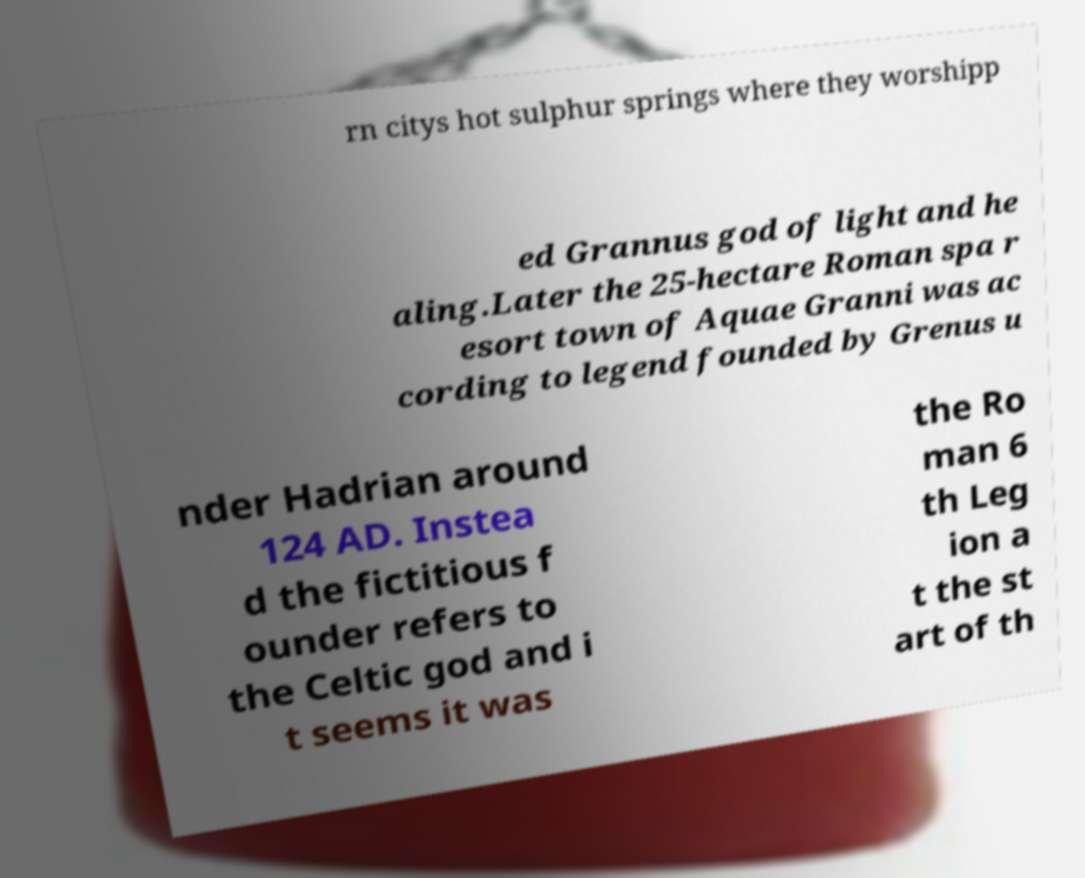Can you accurately transcribe the text from the provided image for me? rn citys hot sulphur springs where they worshipp ed Grannus god of light and he aling.Later the 25-hectare Roman spa r esort town of Aquae Granni was ac cording to legend founded by Grenus u nder Hadrian around 124 AD. Instea d the fictitious f ounder refers to the Celtic god and i t seems it was the Ro man 6 th Leg ion a t the st art of th 